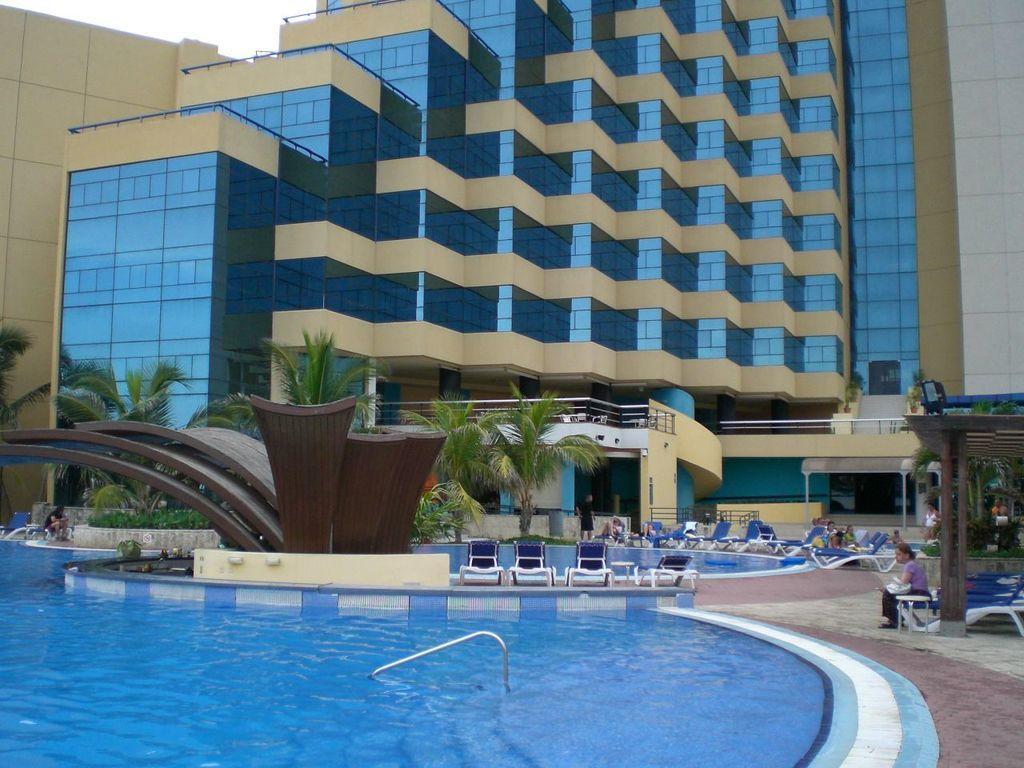How would you summarize this image in a sentence or two? In this image we can see the swimming pool, chairs on which people sitting, trees and the glass building in the background. 